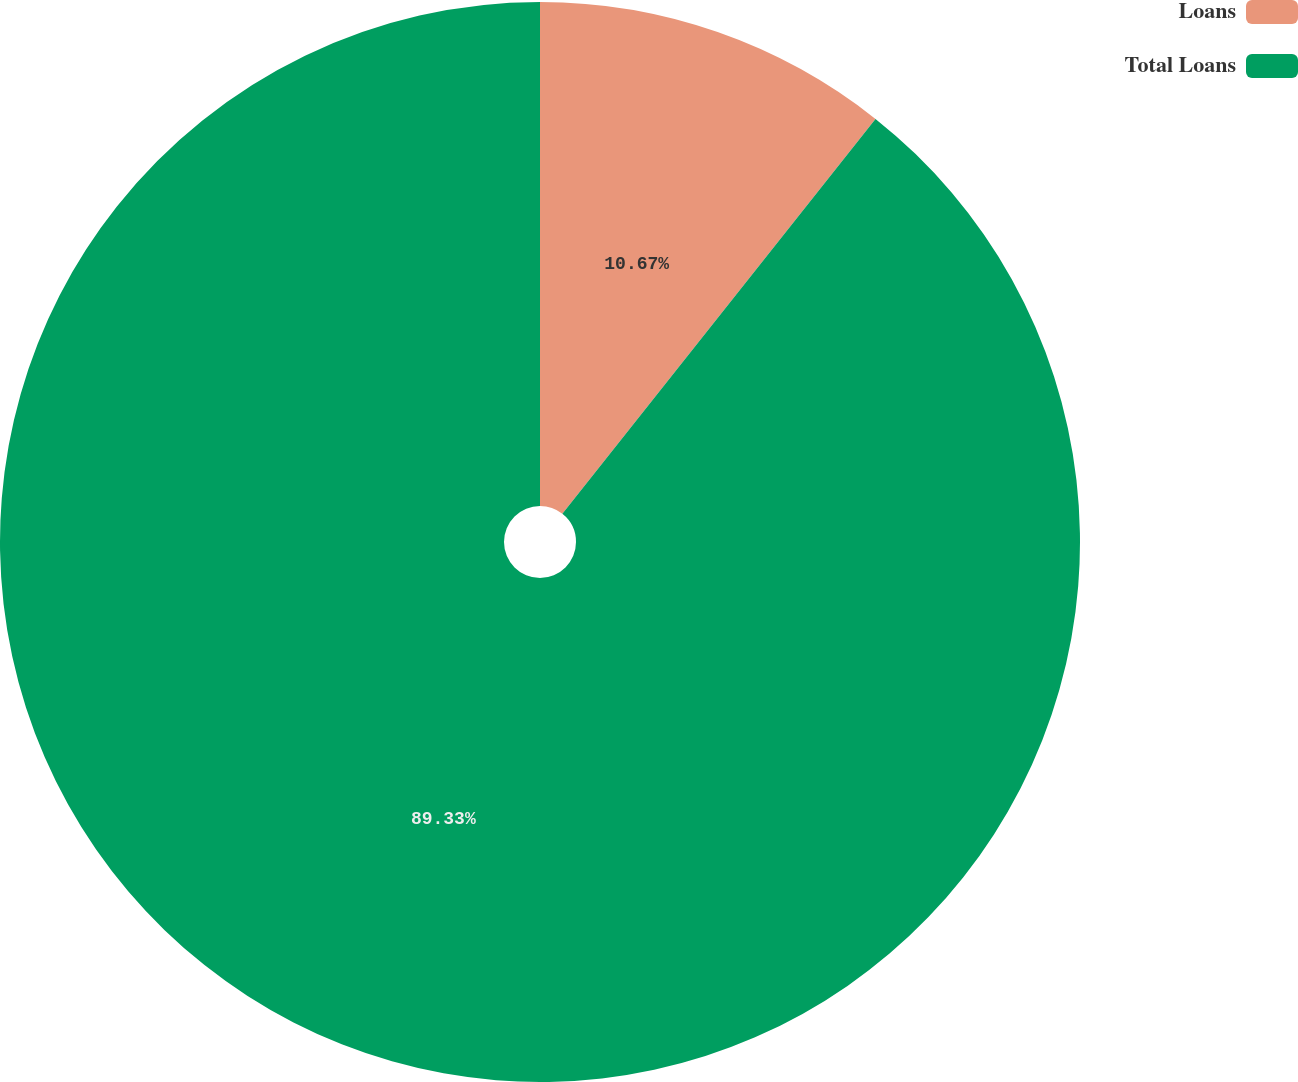<chart> <loc_0><loc_0><loc_500><loc_500><pie_chart><fcel>Loans<fcel>Total Loans<nl><fcel>10.67%<fcel>89.33%<nl></chart> 